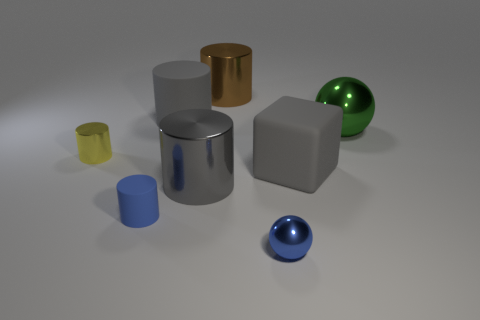There is a large shiny cylinder that is in front of the matte cylinder behind the gray block; what color is it?
Keep it short and to the point. Gray. Is the small blue ball made of the same material as the tiny cylinder that is behind the large rubber block?
Offer a terse response. Yes. There is a metallic cylinder that is behind the ball on the right side of the sphere that is on the left side of the green shiny sphere; what is its color?
Offer a terse response. Brown. Is there anything else that has the same shape as the green thing?
Offer a terse response. Yes. Is the number of big gray metallic spheres greater than the number of tiny balls?
Your answer should be very brief. No. How many cylinders are in front of the big green sphere and on the right side of the yellow shiny thing?
Offer a very short reply. 2. There is a large rubber thing that is to the right of the tiny ball; what number of green metal spheres are to the left of it?
Your answer should be compact. 0. There is a gray rubber object right of the small blue sphere; is it the same size as the rubber object that is behind the small yellow cylinder?
Offer a very short reply. Yes. What number of red shiny cylinders are there?
Provide a short and direct response. 0. How many large blocks have the same material as the big ball?
Offer a very short reply. 0. 